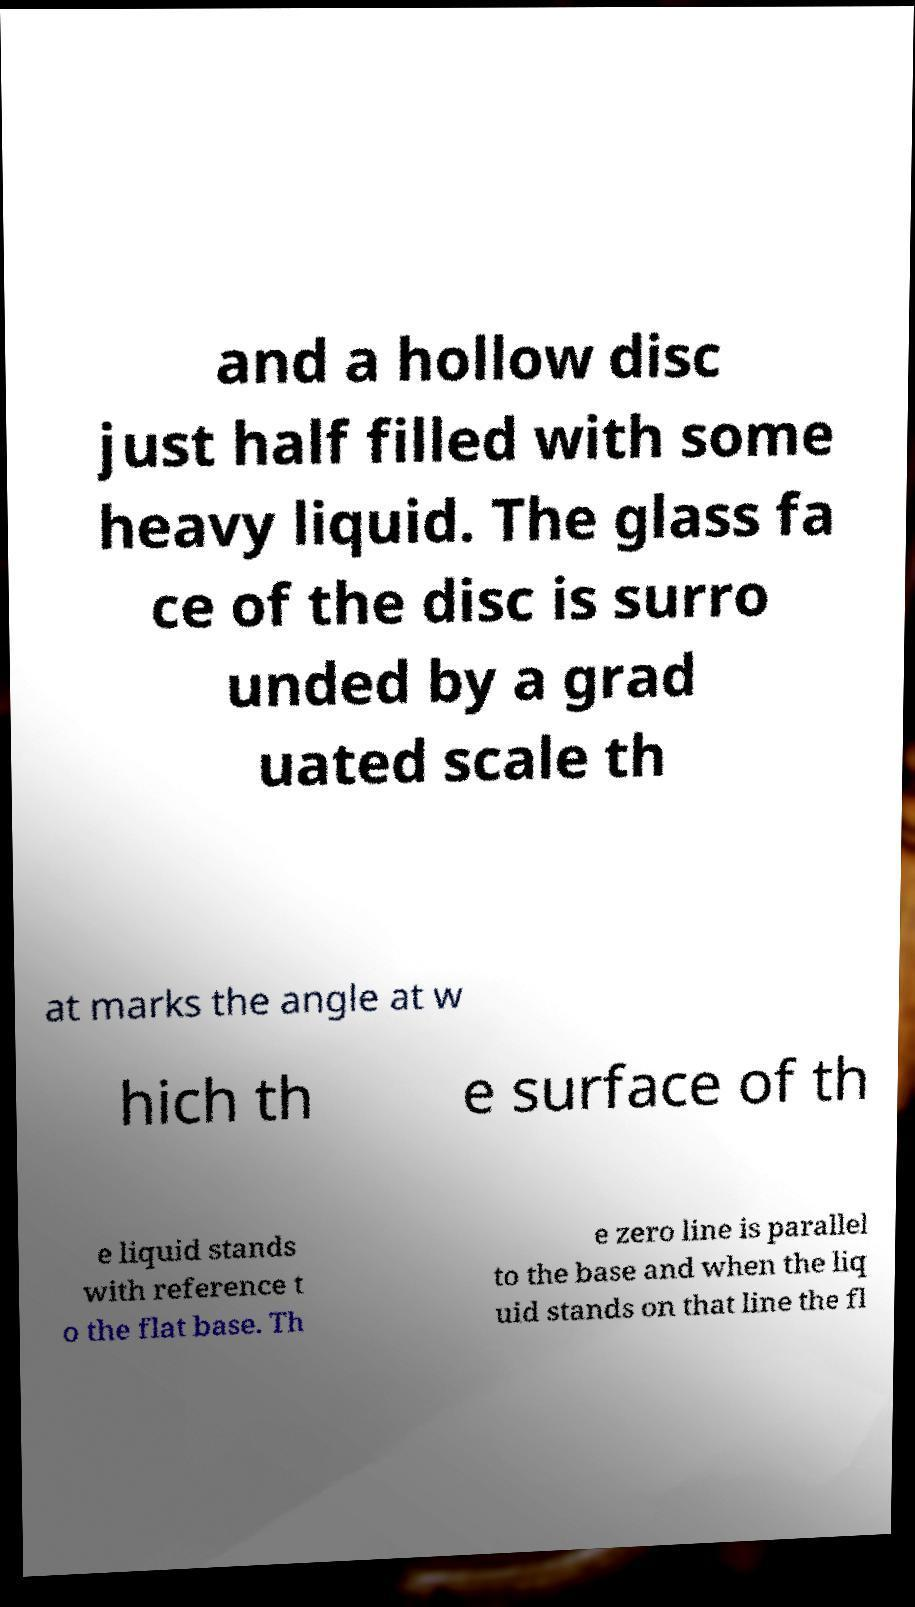For documentation purposes, I need the text within this image transcribed. Could you provide that? and a hollow disc just half filled with some heavy liquid. The glass fa ce of the disc is surro unded by a grad uated scale th at marks the angle at w hich th e surface of th e liquid stands with reference t o the flat base. Th e zero line is parallel to the base and when the liq uid stands on that line the fl 